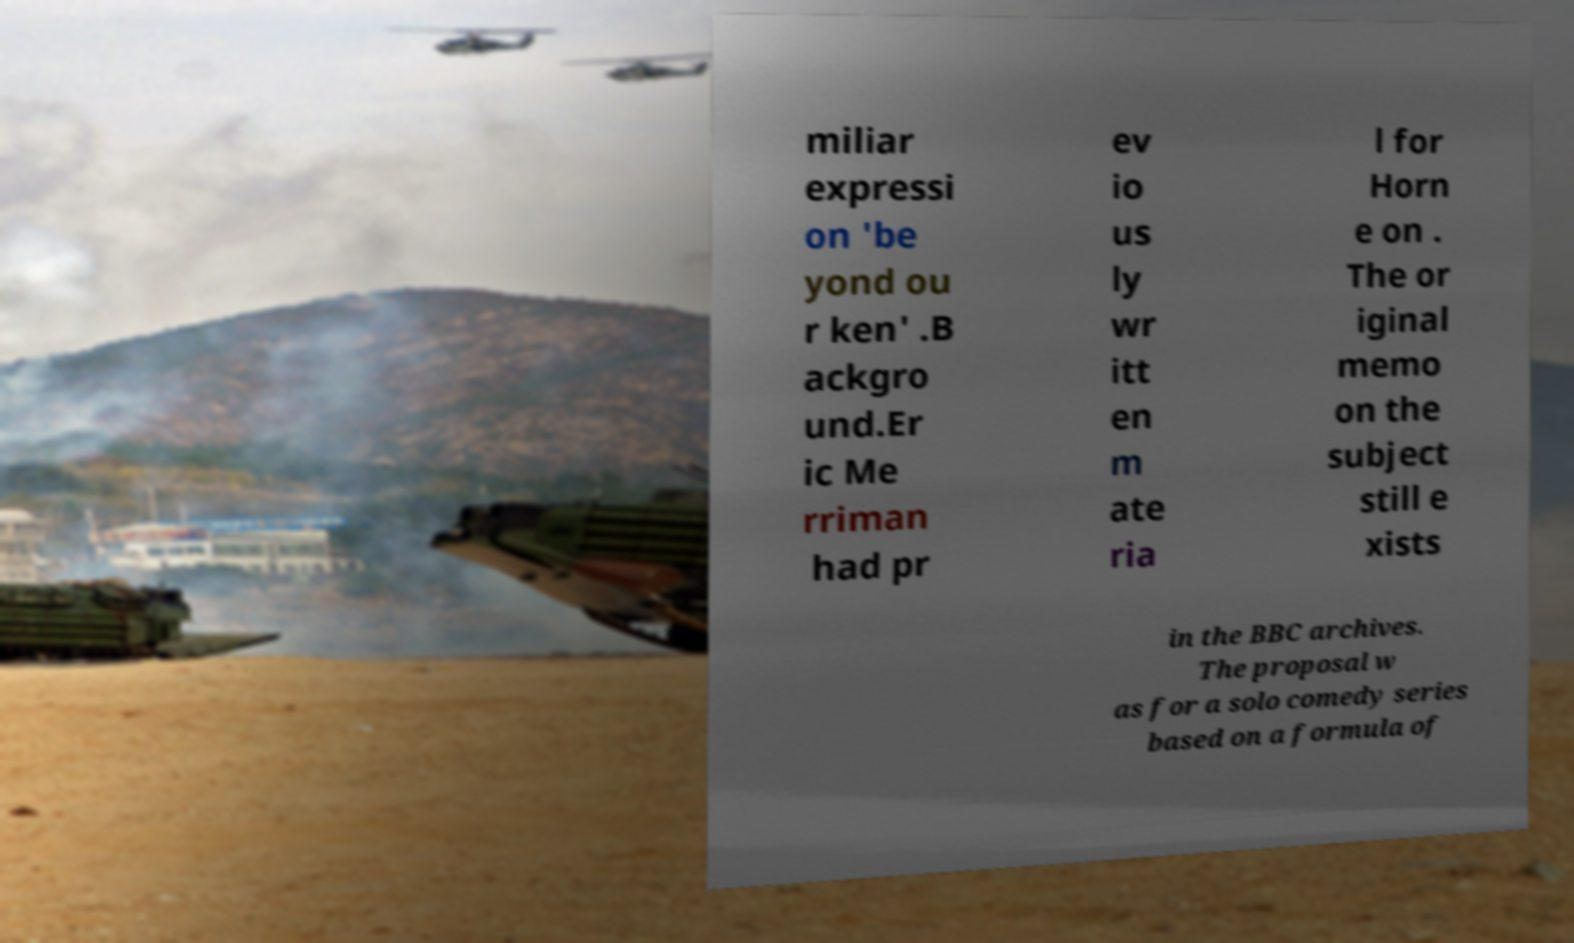Can you read and provide the text displayed in the image?This photo seems to have some interesting text. Can you extract and type it out for me? miliar expressi on 'be yond ou r ken' .B ackgro und.Er ic Me rriman had pr ev io us ly wr itt en m ate ria l for Horn e on . The or iginal memo on the subject still e xists in the BBC archives. The proposal w as for a solo comedy series based on a formula of 